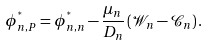<formula> <loc_0><loc_0><loc_500><loc_500>\phi _ { n , P } ^ { ^ { * } } = \phi _ { n , n } ^ { ^ { * } } - \frac { \mu _ { n } } { D _ { n } } \left ( \mathcal { W } _ { n } - \mathcal { C } _ { n } \right ) .</formula> 